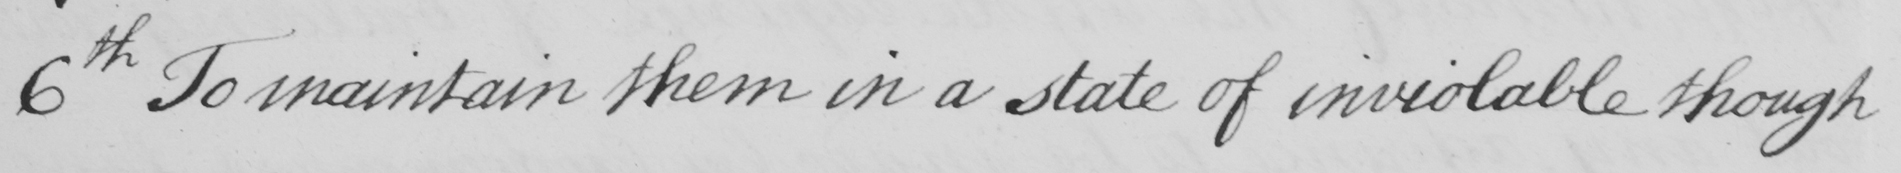Please provide the text content of this handwritten line. 6th. To maintain them in a state of inviolable though 